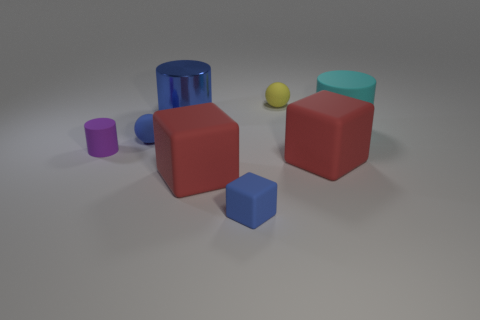Subtract all rubber cylinders. How many cylinders are left? 1 Add 1 tiny yellow spheres. How many objects exist? 9 Subtract all cubes. How many objects are left? 5 Subtract 2 spheres. How many spheres are left? 0 Subtract all cyan balls. How many red blocks are left? 2 Add 1 cyan cylinders. How many cyan cylinders are left? 2 Add 3 yellow matte blocks. How many yellow matte blocks exist? 3 Subtract all yellow balls. How many balls are left? 1 Subtract 0 red cylinders. How many objects are left? 8 Subtract all blue balls. Subtract all red cylinders. How many balls are left? 1 